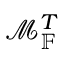<formula> <loc_0><loc_0><loc_500><loc_500>\mathcal { M } _ { \mathbb { F } } ^ { T }</formula> 